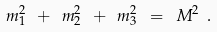<formula> <loc_0><loc_0><loc_500><loc_500>m _ { 1 } ^ { 2 } \ + \ m _ { 2 } ^ { 2 } \ + \ m _ { 3 } ^ { 2 } \ = \ M ^ { 2 } \ .</formula> 